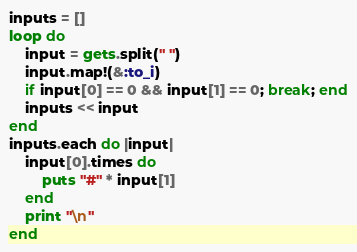<code> <loc_0><loc_0><loc_500><loc_500><_Ruby_>inputs = []
loop do
    input = gets.split(" ")
    input.map!(&:to_i)
    if input[0] == 0 && input[1] == 0; break; end
    inputs << input
end
inputs.each do |input|
    input[0].times do
        puts "#" * input[1]
    end
    print "\n"
end
</code> 